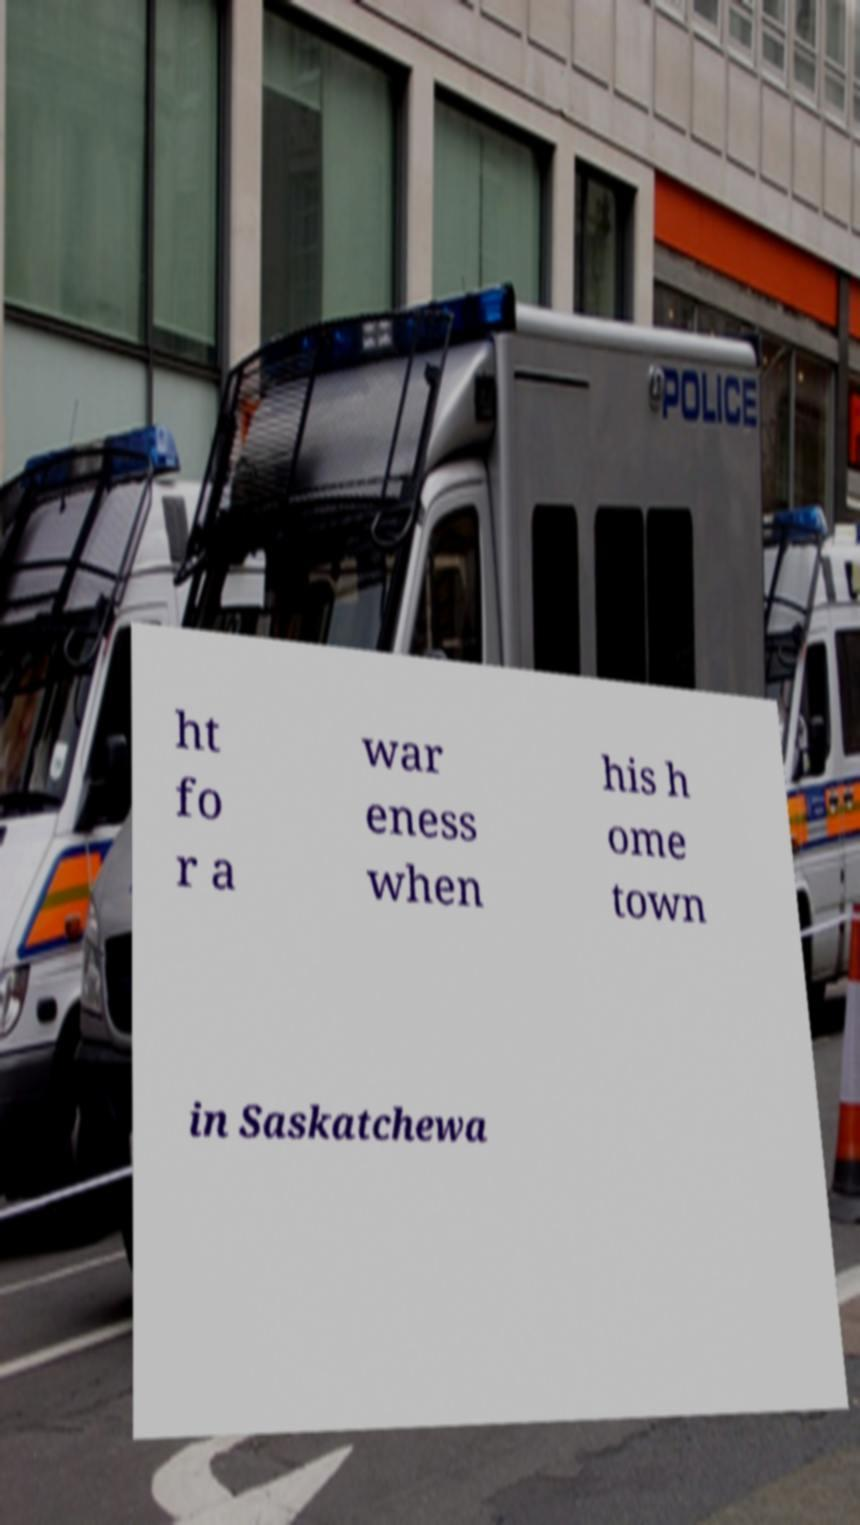For documentation purposes, I need the text within this image transcribed. Could you provide that? ht fo r a war eness when his h ome town in Saskatchewa 